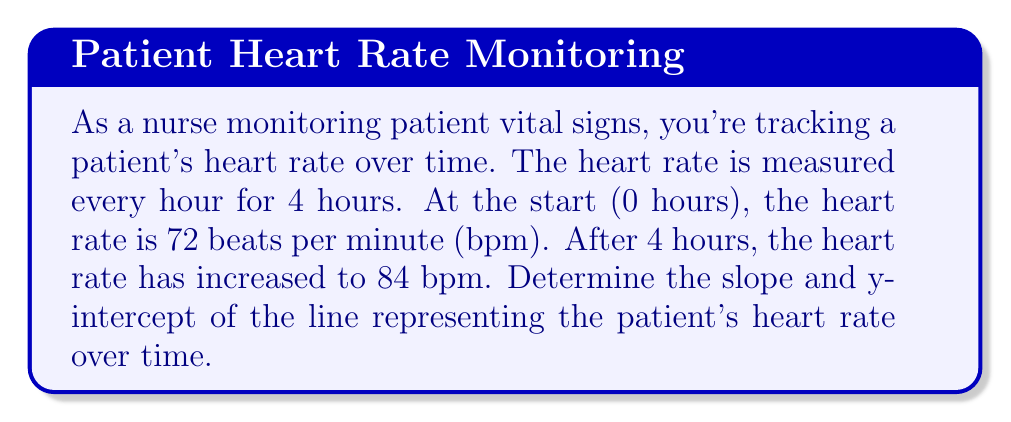What is the answer to this math problem? Let's approach this step-by-step:

1) First, we need to identify our points. We have:
   - At 0 hours: (0, 72)
   - At 4 hours: (4, 84)

2) To find the slope, we use the formula:
   $$ m = \frac{y_2 - y_1}{x_2 - x_1} $$

3) Plugging in our values:
   $$ m = \frac{84 - 72}{4 - 0} = \frac{12}{4} = 3 $$

4) The slope is 3, which means the heart rate is increasing by 3 bpm per hour.

5) To find the y-intercept, we can use the point-slope form of a line:
   $$ y - y_1 = m(x - x_1) $$

6) We can use either point. Let's use (0, 72):
   $$ y - 72 = 3(x - 0) $$

7) Simplify:
   $$ y = 3x + 72 $$

8) The y-intercept is the value of y when x = 0, which is 72.

Therefore, the equation of the line is $y = 3x + 72$, where:
- The slope (m) is 3
- The y-intercept (b) is 72
Answer: Slope: 3, y-intercept: 72 